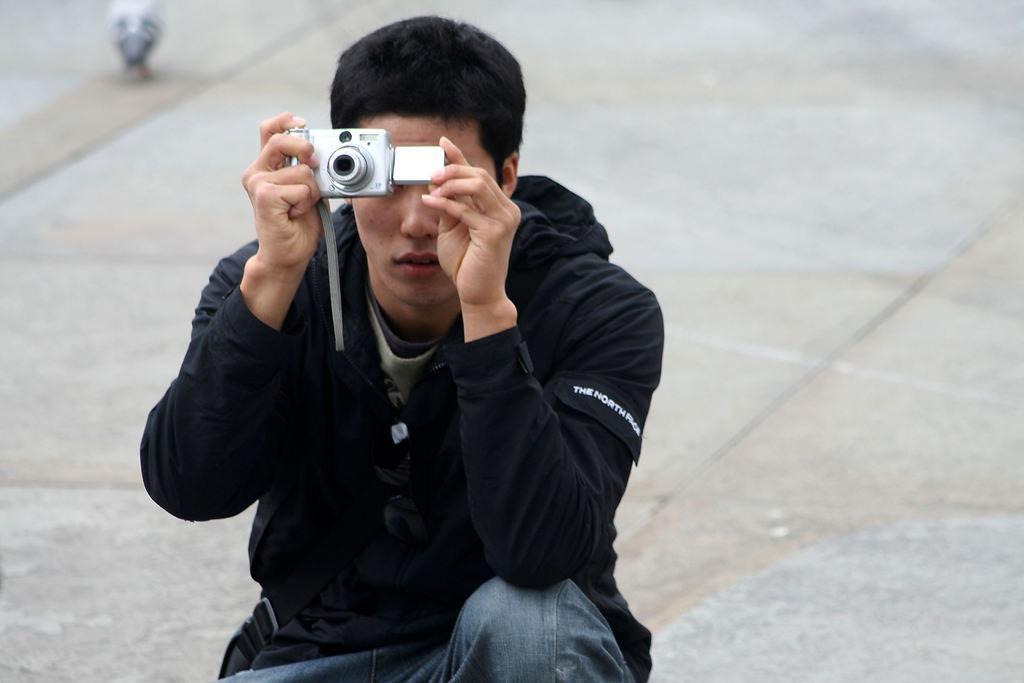In one or two sentences, can you explain what this image depicts? In this picture we can find a person sitting and holding a camera and capturing something. In the background we can find a bird and a floor. 